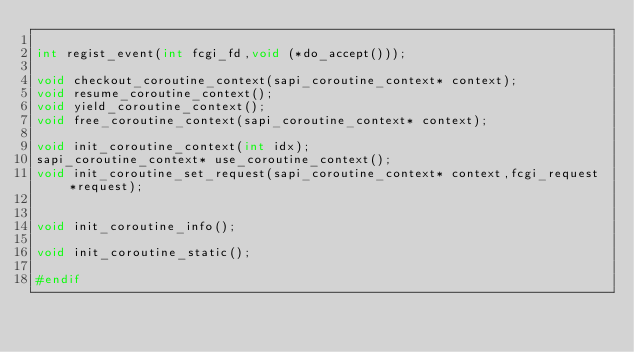<code> <loc_0><loc_0><loc_500><loc_500><_C_>
int regist_event(int fcgi_fd,void (*do_accept()));

void checkout_coroutine_context(sapi_coroutine_context* context);
void resume_coroutine_context();
void yield_coroutine_context();
void free_coroutine_context(sapi_coroutine_context* context);

void init_coroutine_context(int idx);
sapi_coroutine_context* use_coroutine_context();
void init_coroutine_set_request(sapi_coroutine_context* context,fcgi_request *request);


void init_coroutine_info();

void init_coroutine_static();

#endif
</code> 